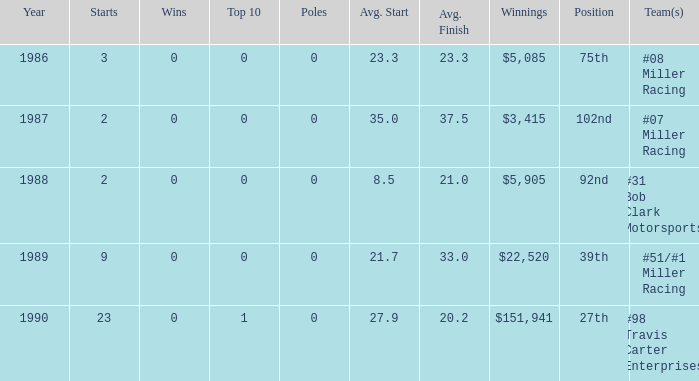What is the most recent year where the average start is 8.5? 1988.0. 